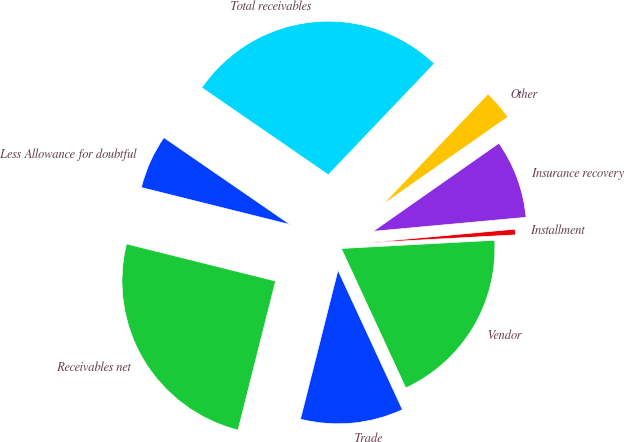Convert chart to OTSL. <chart><loc_0><loc_0><loc_500><loc_500><pie_chart><fcel>Trade<fcel>Vendor<fcel>Installment<fcel>Insurance recovery<fcel>Other<fcel>Total receivables<fcel>Less Allowance for doubtful<fcel>Receivables net<nl><fcel>10.82%<fcel>18.96%<fcel>0.6%<fcel>8.27%<fcel>3.16%<fcel>27.52%<fcel>5.71%<fcel>24.96%<nl></chart> 